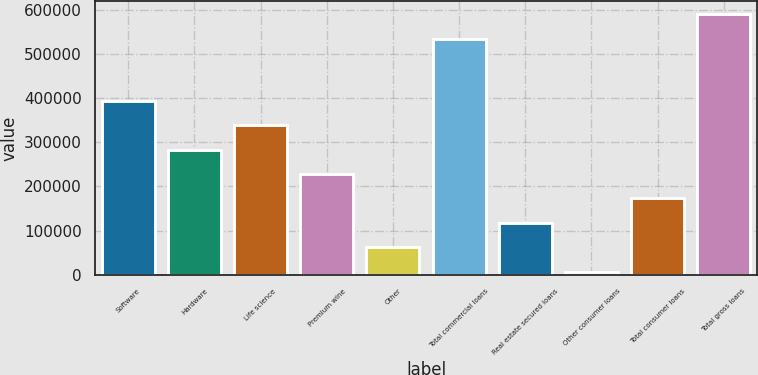Convert chart. <chart><loc_0><loc_0><loc_500><loc_500><bar_chart><fcel>Software<fcel>Hardware<fcel>Life science<fcel>Premium wine<fcel>Other<fcel>Total commercial loans<fcel>Real estate secured loans<fcel>Other consumer loans<fcel>Total consumer loans<fcel>Total gross loans<nl><fcel>393763<fcel>283224<fcel>338494<fcel>227955<fcel>62147.3<fcel>534219<fcel>117417<fcel>6878<fcel>172686<fcel>589488<nl></chart> 